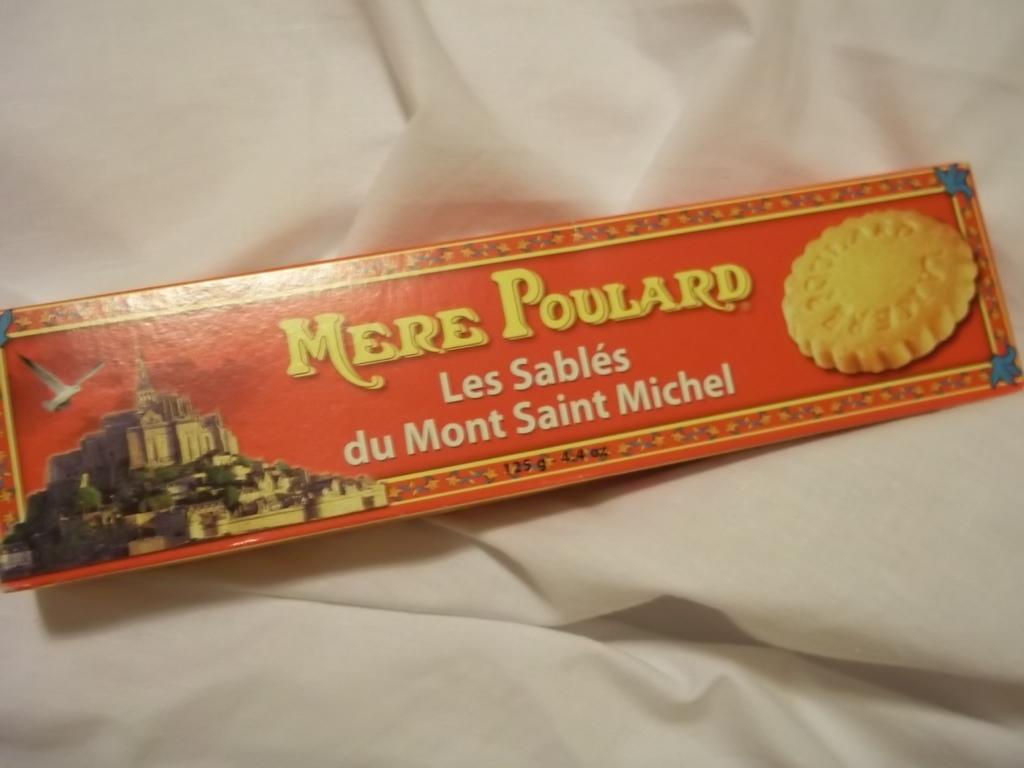What is the main subject of the image? The main subject of the image is a biscuit packet. Where is the biscuit packet located in the image? The biscuit packet is in the center of the image. What else can be seen in the background of the image? Cloth is visible in the background of the image. How many beans are scattered on the grass in the image? There is no grass or beans present in the image; it only features a biscuit packet and cloth in the background. 